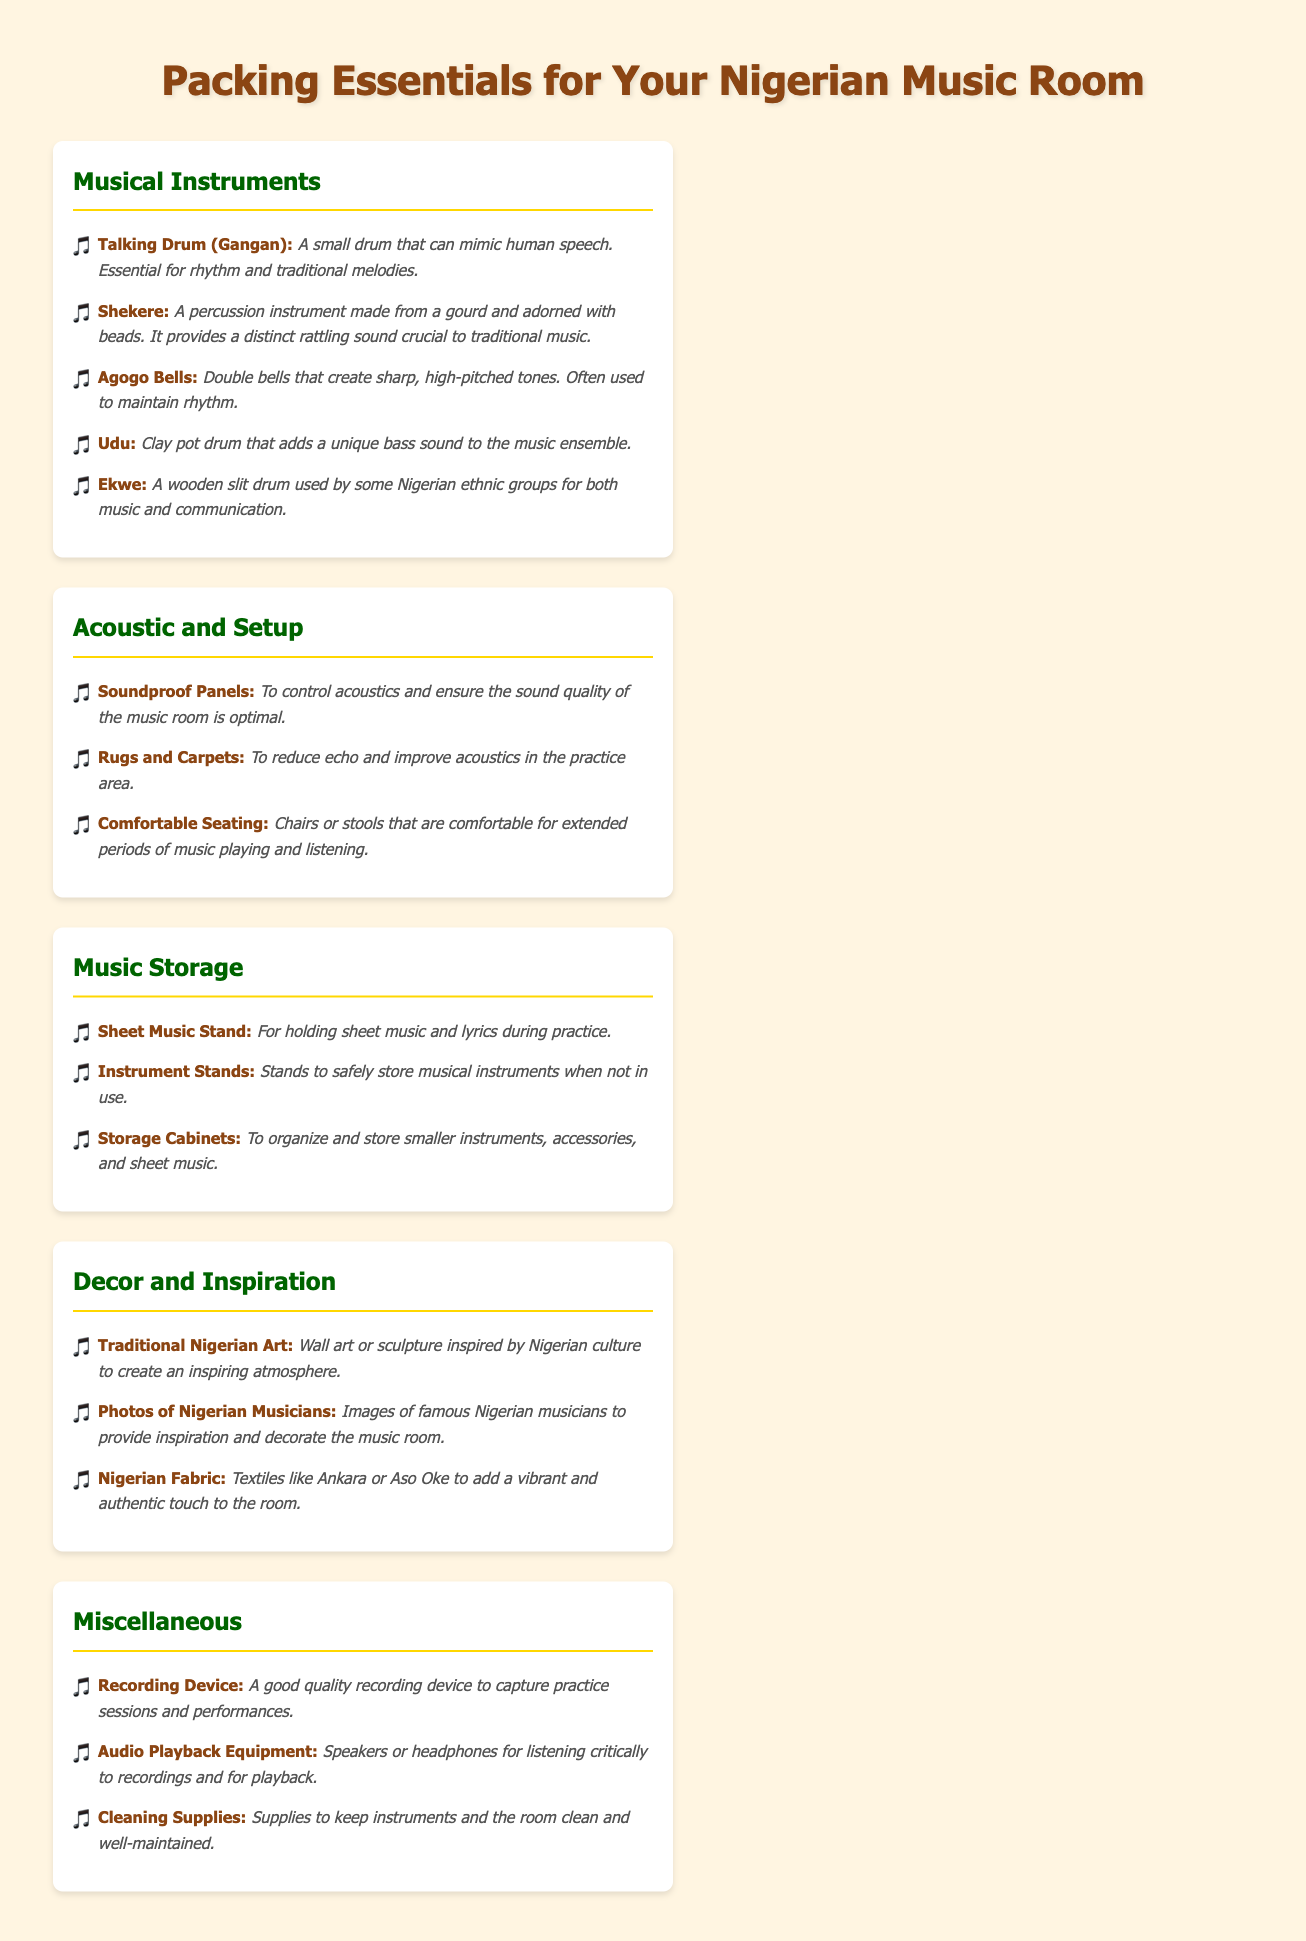What instrument mimics human speech? The Talking Drum (Gangan) can mimic human speech, making it essential for rhythm and traditional melodies.
Answer: Talking Drum (Gangan) What is the purpose of soundproof panels? Soundproof panels are used to control acoustics and ensure the sound quality of the music room is optimal.
Answer: Control acoustics What musical instrument adds a unique bass sound? The Udu is a clay pot drum that adds a unique bass sound to the music ensemble.
Answer: Udu What type of art is suggested for the music room decor? Traditional Nigerian Art is suggested to create an inspiring atmosphere in the music room.
Answer: Traditional Nigerian Art How many items are listed under Music Storage? There are three items listed under Music Storage: Sheet Music Stand, Instrument Stands, and Storage Cabinets.
Answer: Three items What should you use for holding sheet music during practice? A Sheet Music Stand is used for holding sheet music and lyrics during practice.
Answer: Sheet Music Stand What cleaning supplies are mentioned? Cleaning supplies are included to keep instruments and the room clean and well-maintained.
Answer: Cleaning Supplies 